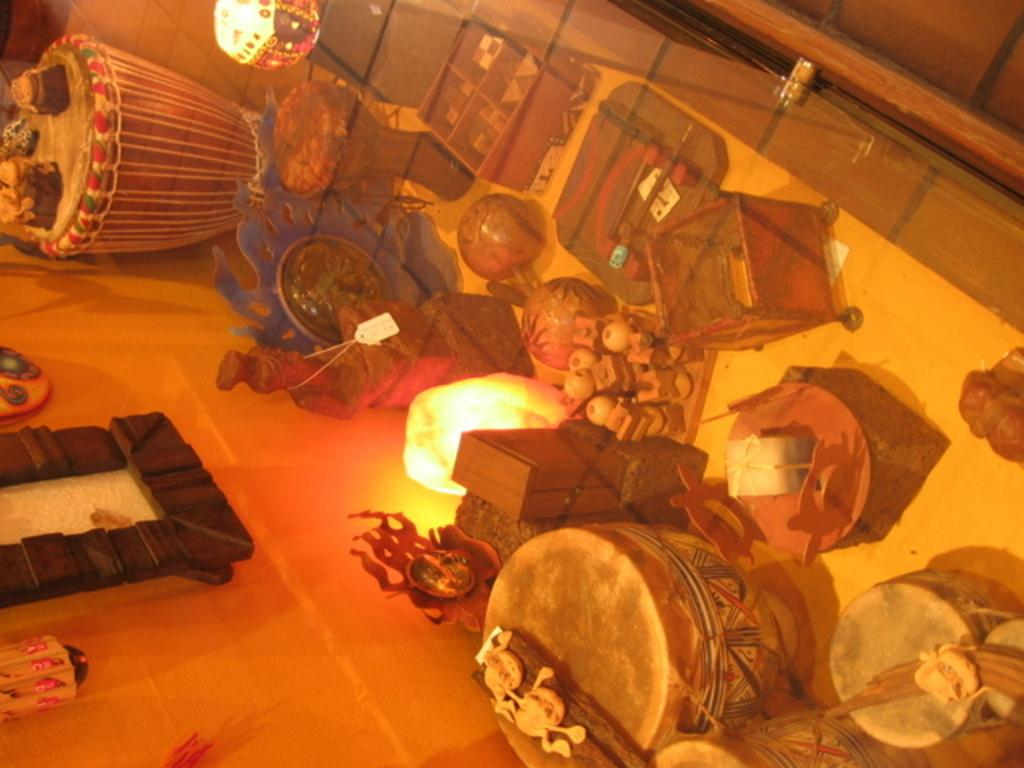What type of objects can be seen in the image? There are musical instruments, lamps, wooden boxes, and objects placed on the floor in the image. Can you describe the objects on the wall in the image? There is a frame on a wall in the image. What material are the lamps made of? The information provided does not specify the material of the lamps. How many musical instruments are visible in the image? The number of musical instruments is not specified in the provided facts. What type of bird can be seen flying near the frame in the image? There is no bird present in the image. What year is depicted in the frame in the image? The information provided does not specify any year or content within the frame. 